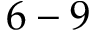Convert formula to latex. <formula><loc_0><loc_0><loc_500><loc_500>6 - 9</formula> 